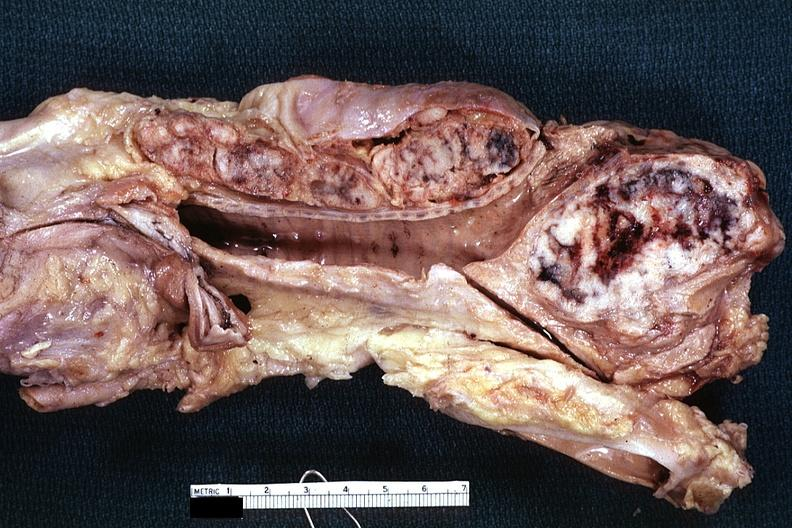s lymph node present?
Answer the question using a single word or phrase. Yes 